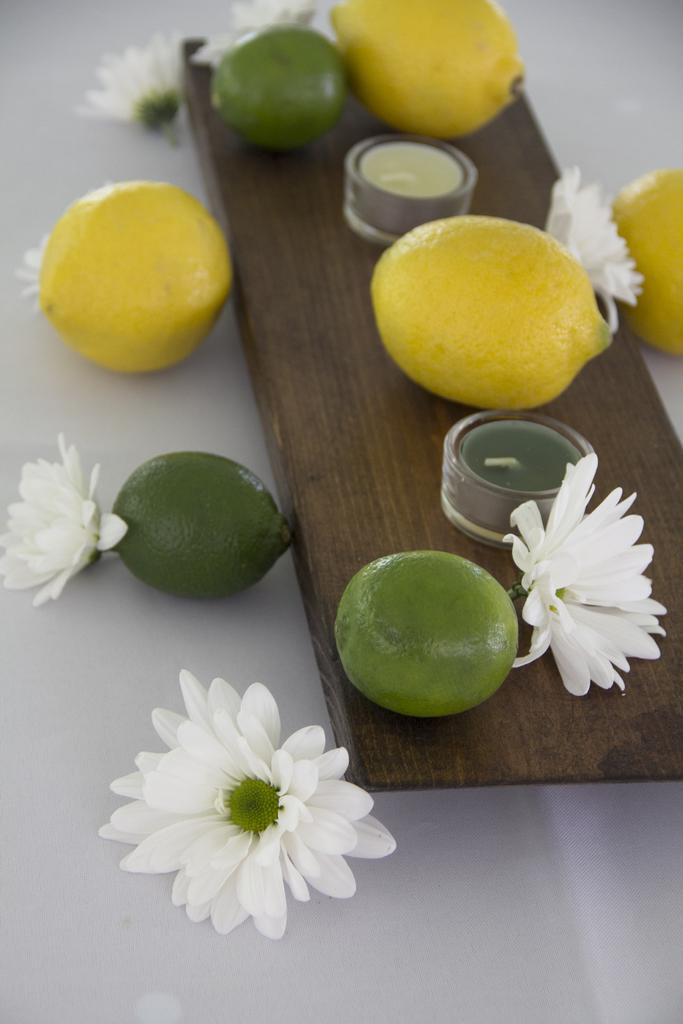What is placed on the wooden board in the image? There are fruits and flowers on a wooden board in the image. Are there any other objects on the wooden board? Yes, there are other objects on the wooden board in the image. What is placed on the white surface in the image? There are fruits and flowers on a white surface in the image. What type of wound can be seen on the scarecrow in the image? There is no scarecrow present in the image, so it is not possible to determine if there is any wound. 